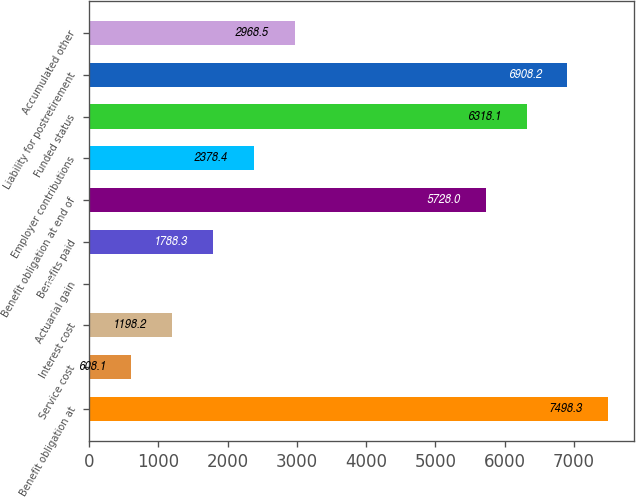<chart> <loc_0><loc_0><loc_500><loc_500><bar_chart><fcel>Benefit obligation at<fcel>Service cost<fcel>Interest cost<fcel>Actuarial gain<fcel>Benefits paid<fcel>Benefit obligation at end of<fcel>Employer contributions<fcel>Funded status<fcel>Liability for postretirement<fcel>Accumulated other<nl><fcel>7498.3<fcel>608.1<fcel>1198.2<fcel>18<fcel>1788.3<fcel>5728<fcel>2378.4<fcel>6318.1<fcel>6908.2<fcel>2968.5<nl></chart> 